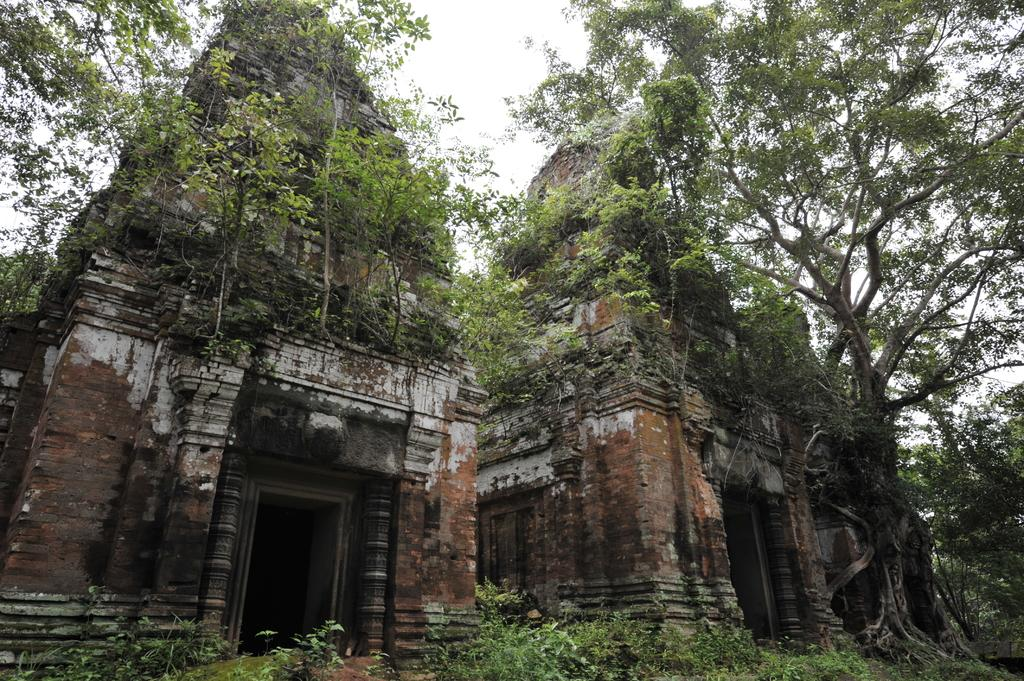What type of structures can be seen in the image? There are old temples in the image. What type of vegetation is present in the image? There are trees and plants in the image. How would you describe the sky in the image? The sky is cloudy in the image. Can you see any details of the steam coming out of the temples in the image? There is no steam present in the image; it features old temples, trees, plants, and a cloudy sky. 